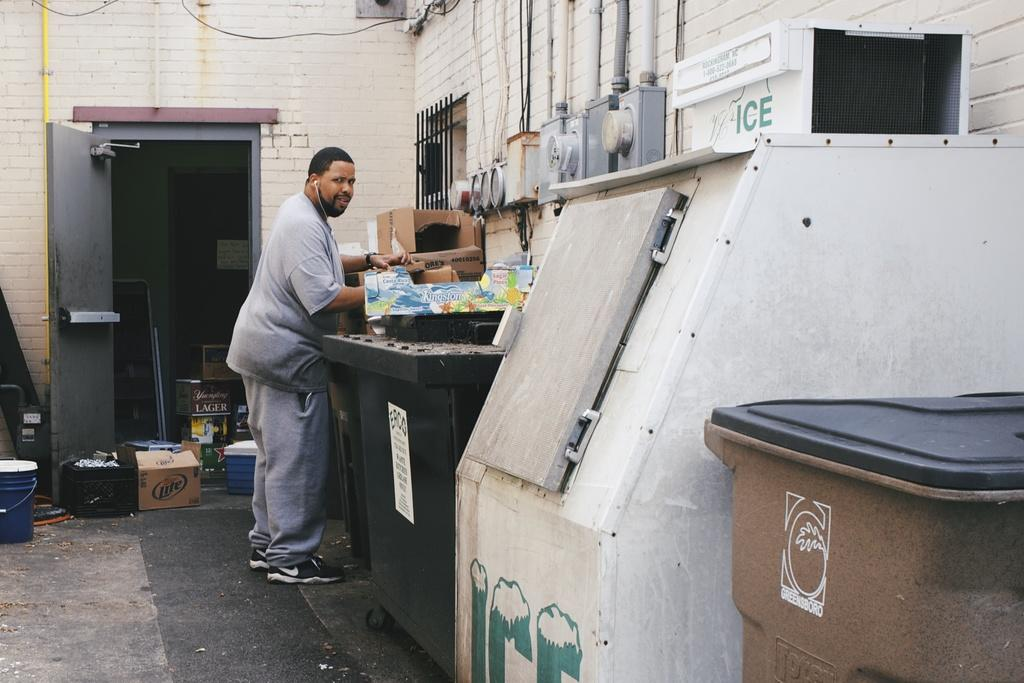<image>
Relay a brief, clear account of the picture shown. A man wearing headphones stands near a white ICE machine 